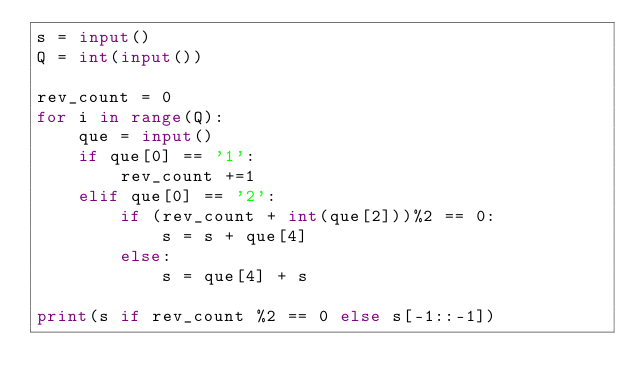Convert code to text. <code><loc_0><loc_0><loc_500><loc_500><_Python_>s = input()
Q = int(input())

rev_count = 0
for i in range(Q):
    que = input()
    if que[0] == '1':
        rev_count +=1
    elif que[0] == '2':
        if (rev_count + int(que[2]))%2 == 0:
            s = s + que[4]
        else:
            s = que[4] + s

print(s if rev_count %2 == 0 else s[-1::-1])
</code> 